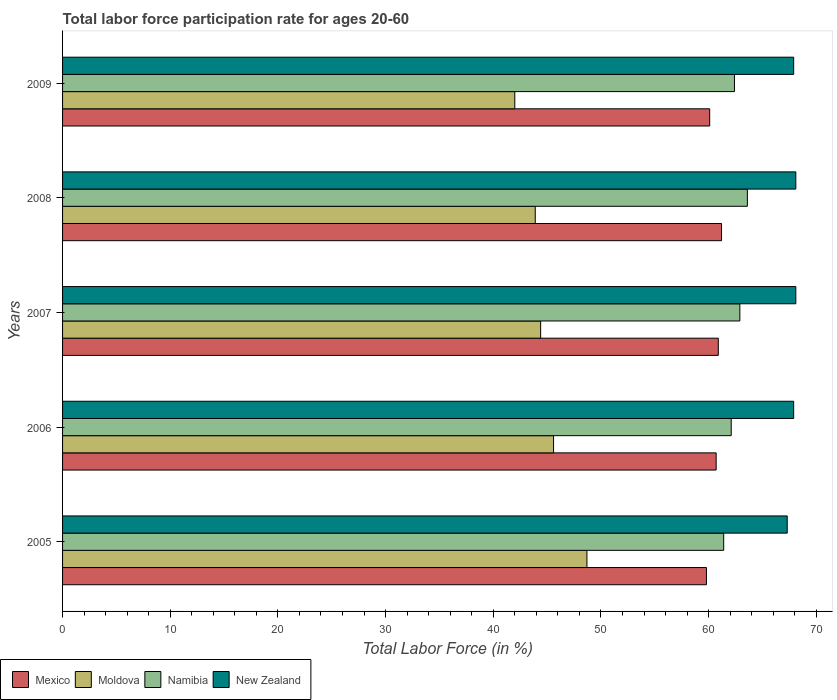How many groups of bars are there?
Keep it short and to the point. 5. Are the number of bars per tick equal to the number of legend labels?
Ensure brevity in your answer.  Yes. How many bars are there on the 2nd tick from the bottom?
Ensure brevity in your answer.  4. In how many cases, is the number of bars for a given year not equal to the number of legend labels?
Your answer should be very brief. 0. What is the labor force participation rate in Mexico in 2005?
Your answer should be very brief. 59.8. Across all years, what is the maximum labor force participation rate in Namibia?
Offer a terse response. 63.6. Across all years, what is the minimum labor force participation rate in New Zealand?
Give a very brief answer. 67.3. In which year was the labor force participation rate in Mexico maximum?
Offer a very short reply. 2008. What is the total labor force participation rate in New Zealand in the graph?
Your answer should be compact. 339.3. What is the difference between the labor force participation rate in New Zealand in 2007 and that in 2009?
Ensure brevity in your answer.  0.2. What is the difference between the labor force participation rate in Namibia in 2005 and the labor force participation rate in Mexico in 2008?
Provide a short and direct response. 0.2. What is the average labor force participation rate in New Zealand per year?
Your answer should be compact. 67.86. In the year 2007, what is the difference between the labor force participation rate in Moldova and labor force participation rate in Namibia?
Ensure brevity in your answer.  -18.5. What is the ratio of the labor force participation rate in Moldova in 2006 to that in 2008?
Offer a very short reply. 1.04. What is the difference between the highest and the second highest labor force participation rate in Mexico?
Your answer should be very brief. 0.3. What is the difference between the highest and the lowest labor force participation rate in New Zealand?
Offer a very short reply. 0.8. What does the 4th bar from the top in 2009 represents?
Offer a very short reply. Mexico. What does the 2nd bar from the bottom in 2007 represents?
Your response must be concise. Moldova. How many bars are there?
Your answer should be very brief. 20. Are the values on the major ticks of X-axis written in scientific E-notation?
Your response must be concise. No. Does the graph contain grids?
Give a very brief answer. No. How are the legend labels stacked?
Your answer should be compact. Horizontal. What is the title of the graph?
Offer a very short reply. Total labor force participation rate for ages 20-60. What is the Total Labor Force (in %) of Mexico in 2005?
Your answer should be compact. 59.8. What is the Total Labor Force (in %) in Moldova in 2005?
Your answer should be very brief. 48.7. What is the Total Labor Force (in %) of Namibia in 2005?
Make the answer very short. 61.4. What is the Total Labor Force (in %) in New Zealand in 2005?
Provide a short and direct response. 67.3. What is the Total Labor Force (in %) in Mexico in 2006?
Your answer should be very brief. 60.7. What is the Total Labor Force (in %) of Moldova in 2006?
Your answer should be very brief. 45.6. What is the Total Labor Force (in %) in Namibia in 2006?
Offer a very short reply. 62.1. What is the Total Labor Force (in %) in New Zealand in 2006?
Your answer should be compact. 67.9. What is the Total Labor Force (in %) in Mexico in 2007?
Keep it short and to the point. 60.9. What is the Total Labor Force (in %) of Moldova in 2007?
Provide a short and direct response. 44.4. What is the Total Labor Force (in %) of Namibia in 2007?
Your answer should be compact. 62.9. What is the Total Labor Force (in %) in New Zealand in 2007?
Your answer should be compact. 68.1. What is the Total Labor Force (in %) of Mexico in 2008?
Give a very brief answer. 61.2. What is the Total Labor Force (in %) of Moldova in 2008?
Provide a short and direct response. 43.9. What is the Total Labor Force (in %) in Namibia in 2008?
Provide a succinct answer. 63.6. What is the Total Labor Force (in %) in New Zealand in 2008?
Your answer should be compact. 68.1. What is the Total Labor Force (in %) in Mexico in 2009?
Offer a very short reply. 60.1. What is the Total Labor Force (in %) in Moldova in 2009?
Your response must be concise. 42. What is the Total Labor Force (in %) in Namibia in 2009?
Keep it short and to the point. 62.4. What is the Total Labor Force (in %) of New Zealand in 2009?
Make the answer very short. 67.9. Across all years, what is the maximum Total Labor Force (in %) of Mexico?
Offer a very short reply. 61.2. Across all years, what is the maximum Total Labor Force (in %) of Moldova?
Make the answer very short. 48.7. Across all years, what is the maximum Total Labor Force (in %) in Namibia?
Provide a succinct answer. 63.6. Across all years, what is the maximum Total Labor Force (in %) of New Zealand?
Make the answer very short. 68.1. Across all years, what is the minimum Total Labor Force (in %) in Mexico?
Ensure brevity in your answer.  59.8. Across all years, what is the minimum Total Labor Force (in %) of Namibia?
Provide a succinct answer. 61.4. Across all years, what is the minimum Total Labor Force (in %) in New Zealand?
Give a very brief answer. 67.3. What is the total Total Labor Force (in %) of Mexico in the graph?
Your answer should be very brief. 302.7. What is the total Total Labor Force (in %) in Moldova in the graph?
Give a very brief answer. 224.6. What is the total Total Labor Force (in %) in Namibia in the graph?
Give a very brief answer. 312.4. What is the total Total Labor Force (in %) of New Zealand in the graph?
Make the answer very short. 339.3. What is the difference between the Total Labor Force (in %) of New Zealand in 2005 and that in 2006?
Provide a short and direct response. -0.6. What is the difference between the Total Labor Force (in %) of Mexico in 2005 and that in 2007?
Your answer should be compact. -1.1. What is the difference between the Total Labor Force (in %) of Moldova in 2005 and that in 2007?
Provide a succinct answer. 4.3. What is the difference between the Total Labor Force (in %) in Namibia in 2005 and that in 2007?
Offer a very short reply. -1.5. What is the difference between the Total Labor Force (in %) in Mexico in 2005 and that in 2008?
Provide a succinct answer. -1.4. What is the difference between the Total Labor Force (in %) of Moldova in 2005 and that in 2008?
Your response must be concise. 4.8. What is the difference between the Total Labor Force (in %) of Namibia in 2005 and that in 2008?
Keep it short and to the point. -2.2. What is the difference between the Total Labor Force (in %) of New Zealand in 2005 and that in 2008?
Provide a succinct answer. -0.8. What is the difference between the Total Labor Force (in %) in Mexico in 2005 and that in 2009?
Your answer should be compact. -0.3. What is the difference between the Total Labor Force (in %) in Moldova in 2005 and that in 2009?
Make the answer very short. 6.7. What is the difference between the Total Labor Force (in %) in Moldova in 2006 and that in 2007?
Your answer should be very brief. 1.2. What is the difference between the Total Labor Force (in %) of New Zealand in 2006 and that in 2007?
Keep it short and to the point. -0.2. What is the difference between the Total Labor Force (in %) in Mexico in 2006 and that in 2008?
Your response must be concise. -0.5. What is the difference between the Total Labor Force (in %) in Moldova in 2006 and that in 2008?
Provide a succinct answer. 1.7. What is the difference between the Total Labor Force (in %) of Namibia in 2006 and that in 2008?
Provide a succinct answer. -1.5. What is the difference between the Total Labor Force (in %) in Moldova in 2006 and that in 2009?
Keep it short and to the point. 3.6. What is the difference between the Total Labor Force (in %) of Namibia in 2006 and that in 2009?
Keep it short and to the point. -0.3. What is the difference between the Total Labor Force (in %) in Mexico in 2007 and that in 2008?
Make the answer very short. -0.3. What is the difference between the Total Labor Force (in %) in Moldova in 2007 and that in 2008?
Offer a very short reply. 0.5. What is the difference between the Total Labor Force (in %) of Namibia in 2007 and that in 2008?
Offer a terse response. -0.7. What is the difference between the Total Labor Force (in %) of Mexico in 2007 and that in 2009?
Provide a succinct answer. 0.8. What is the difference between the Total Labor Force (in %) in Namibia in 2007 and that in 2009?
Provide a short and direct response. 0.5. What is the difference between the Total Labor Force (in %) in New Zealand in 2007 and that in 2009?
Keep it short and to the point. 0.2. What is the difference between the Total Labor Force (in %) of Mexico in 2008 and that in 2009?
Offer a terse response. 1.1. What is the difference between the Total Labor Force (in %) in Moldova in 2008 and that in 2009?
Ensure brevity in your answer.  1.9. What is the difference between the Total Labor Force (in %) in Mexico in 2005 and the Total Labor Force (in %) in Namibia in 2006?
Make the answer very short. -2.3. What is the difference between the Total Labor Force (in %) in Mexico in 2005 and the Total Labor Force (in %) in New Zealand in 2006?
Your answer should be very brief. -8.1. What is the difference between the Total Labor Force (in %) of Moldova in 2005 and the Total Labor Force (in %) of New Zealand in 2006?
Your answer should be compact. -19.2. What is the difference between the Total Labor Force (in %) in Mexico in 2005 and the Total Labor Force (in %) in New Zealand in 2007?
Keep it short and to the point. -8.3. What is the difference between the Total Labor Force (in %) of Moldova in 2005 and the Total Labor Force (in %) of Namibia in 2007?
Give a very brief answer. -14.2. What is the difference between the Total Labor Force (in %) of Moldova in 2005 and the Total Labor Force (in %) of New Zealand in 2007?
Provide a short and direct response. -19.4. What is the difference between the Total Labor Force (in %) of Namibia in 2005 and the Total Labor Force (in %) of New Zealand in 2007?
Give a very brief answer. -6.7. What is the difference between the Total Labor Force (in %) in Mexico in 2005 and the Total Labor Force (in %) in New Zealand in 2008?
Offer a terse response. -8.3. What is the difference between the Total Labor Force (in %) in Moldova in 2005 and the Total Labor Force (in %) in Namibia in 2008?
Provide a short and direct response. -14.9. What is the difference between the Total Labor Force (in %) in Moldova in 2005 and the Total Labor Force (in %) in New Zealand in 2008?
Offer a terse response. -19.4. What is the difference between the Total Labor Force (in %) of Mexico in 2005 and the Total Labor Force (in %) of Moldova in 2009?
Provide a succinct answer. 17.8. What is the difference between the Total Labor Force (in %) in Mexico in 2005 and the Total Labor Force (in %) in New Zealand in 2009?
Make the answer very short. -8.1. What is the difference between the Total Labor Force (in %) in Moldova in 2005 and the Total Labor Force (in %) in Namibia in 2009?
Keep it short and to the point. -13.7. What is the difference between the Total Labor Force (in %) of Moldova in 2005 and the Total Labor Force (in %) of New Zealand in 2009?
Your response must be concise. -19.2. What is the difference between the Total Labor Force (in %) of Namibia in 2005 and the Total Labor Force (in %) of New Zealand in 2009?
Ensure brevity in your answer.  -6.5. What is the difference between the Total Labor Force (in %) in Moldova in 2006 and the Total Labor Force (in %) in Namibia in 2007?
Ensure brevity in your answer.  -17.3. What is the difference between the Total Labor Force (in %) of Moldova in 2006 and the Total Labor Force (in %) of New Zealand in 2007?
Offer a very short reply. -22.5. What is the difference between the Total Labor Force (in %) of Mexico in 2006 and the Total Labor Force (in %) of Namibia in 2008?
Your answer should be very brief. -2.9. What is the difference between the Total Labor Force (in %) in Moldova in 2006 and the Total Labor Force (in %) in Namibia in 2008?
Your response must be concise. -18. What is the difference between the Total Labor Force (in %) in Moldova in 2006 and the Total Labor Force (in %) in New Zealand in 2008?
Your answer should be compact. -22.5. What is the difference between the Total Labor Force (in %) of Moldova in 2006 and the Total Labor Force (in %) of Namibia in 2009?
Offer a very short reply. -16.8. What is the difference between the Total Labor Force (in %) in Moldova in 2006 and the Total Labor Force (in %) in New Zealand in 2009?
Ensure brevity in your answer.  -22.3. What is the difference between the Total Labor Force (in %) of Mexico in 2007 and the Total Labor Force (in %) of Moldova in 2008?
Keep it short and to the point. 17. What is the difference between the Total Labor Force (in %) of Mexico in 2007 and the Total Labor Force (in %) of New Zealand in 2008?
Your answer should be compact. -7.2. What is the difference between the Total Labor Force (in %) of Moldova in 2007 and the Total Labor Force (in %) of Namibia in 2008?
Your response must be concise. -19.2. What is the difference between the Total Labor Force (in %) of Moldova in 2007 and the Total Labor Force (in %) of New Zealand in 2008?
Offer a terse response. -23.7. What is the difference between the Total Labor Force (in %) in Namibia in 2007 and the Total Labor Force (in %) in New Zealand in 2008?
Your answer should be compact. -5.2. What is the difference between the Total Labor Force (in %) in Mexico in 2007 and the Total Labor Force (in %) in Moldova in 2009?
Ensure brevity in your answer.  18.9. What is the difference between the Total Labor Force (in %) in Mexico in 2007 and the Total Labor Force (in %) in New Zealand in 2009?
Offer a terse response. -7. What is the difference between the Total Labor Force (in %) in Moldova in 2007 and the Total Labor Force (in %) in New Zealand in 2009?
Your answer should be very brief. -23.5. What is the difference between the Total Labor Force (in %) in Namibia in 2007 and the Total Labor Force (in %) in New Zealand in 2009?
Keep it short and to the point. -5. What is the difference between the Total Labor Force (in %) of Mexico in 2008 and the Total Labor Force (in %) of Namibia in 2009?
Give a very brief answer. -1.2. What is the difference between the Total Labor Force (in %) in Moldova in 2008 and the Total Labor Force (in %) in Namibia in 2009?
Keep it short and to the point. -18.5. What is the difference between the Total Labor Force (in %) of Namibia in 2008 and the Total Labor Force (in %) of New Zealand in 2009?
Provide a succinct answer. -4.3. What is the average Total Labor Force (in %) of Mexico per year?
Your response must be concise. 60.54. What is the average Total Labor Force (in %) of Moldova per year?
Provide a succinct answer. 44.92. What is the average Total Labor Force (in %) in Namibia per year?
Your answer should be very brief. 62.48. What is the average Total Labor Force (in %) in New Zealand per year?
Your answer should be compact. 67.86. In the year 2005, what is the difference between the Total Labor Force (in %) of Moldova and Total Labor Force (in %) of Namibia?
Your answer should be compact. -12.7. In the year 2005, what is the difference between the Total Labor Force (in %) of Moldova and Total Labor Force (in %) of New Zealand?
Offer a very short reply. -18.6. In the year 2005, what is the difference between the Total Labor Force (in %) of Namibia and Total Labor Force (in %) of New Zealand?
Your response must be concise. -5.9. In the year 2006, what is the difference between the Total Labor Force (in %) in Mexico and Total Labor Force (in %) in Moldova?
Your response must be concise. 15.1. In the year 2006, what is the difference between the Total Labor Force (in %) of Mexico and Total Labor Force (in %) of Namibia?
Offer a terse response. -1.4. In the year 2006, what is the difference between the Total Labor Force (in %) in Mexico and Total Labor Force (in %) in New Zealand?
Offer a very short reply. -7.2. In the year 2006, what is the difference between the Total Labor Force (in %) of Moldova and Total Labor Force (in %) of Namibia?
Give a very brief answer. -16.5. In the year 2006, what is the difference between the Total Labor Force (in %) in Moldova and Total Labor Force (in %) in New Zealand?
Make the answer very short. -22.3. In the year 2006, what is the difference between the Total Labor Force (in %) in Namibia and Total Labor Force (in %) in New Zealand?
Your answer should be compact. -5.8. In the year 2007, what is the difference between the Total Labor Force (in %) of Mexico and Total Labor Force (in %) of Namibia?
Provide a succinct answer. -2. In the year 2007, what is the difference between the Total Labor Force (in %) of Mexico and Total Labor Force (in %) of New Zealand?
Provide a succinct answer. -7.2. In the year 2007, what is the difference between the Total Labor Force (in %) of Moldova and Total Labor Force (in %) of Namibia?
Provide a succinct answer. -18.5. In the year 2007, what is the difference between the Total Labor Force (in %) in Moldova and Total Labor Force (in %) in New Zealand?
Give a very brief answer. -23.7. In the year 2008, what is the difference between the Total Labor Force (in %) of Mexico and Total Labor Force (in %) of Namibia?
Offer a terse response. -2.4. In the year 2008, what is the difference between the Total Labor Force (in %) in Mexico and Total Labor Force (in %) in New Zealand?
Give a very brief answer. -6.9. In the year 2008, what is the difference between the Total Labor Force (in %) in Moldova and Total Labor Force (in %) in Namibia?
Your response must be concise. -19.7. In the year 2008, what is the difference between the Total Labor Force (in %) of Moldova and Total Labor Force (in %) of New Zealand?
Make the answer very short. -24.2. In the year 2008, what is the difference between the Total Labor Force (in %) in Namibia and Total Labor Force (in %) in New Zealand?
Your answer should be very brief. -4.5. In the year 2009, what is the difference between the Total Labor Force (in %) in Mexico and Total Labor Force (in %) in New Zealand?
Give a very brief answer. -7.8. In the year 2009, what is the difference between the Total Labor Force (in %) of Moldova and Total Labor Force (in %) of Namibia?
Ensure brevity in your answer.  -20.4. In the year 2009, what is the difference between the Total Labor Force (in %) of Moldova and Total Labor Force (in %) of New Zealand?
Offer a terse response. -25.9. In the year 2009, what is the difference between the Total Labor Force (in %) of Namibia and Total Labor Force (in %) of New Zealand?
Provide a succinct answer. -5.5. What is the ratio of the Total Labor Force (in %) in Mexico in 2005 to that in 2006?
Your answer should be compact. 0.99. What is the ratio of the Total Labor Force (in %) in Moldova in 2005 to that in 2006?
Your answer should be very brief. 1.07. What is the ratio of the Total Labor Force (in %) in Namibia in 2005 to that in 2006?
Your response must be concise. 0.99. What is the ratio of the Total Labor Force (in %) of Mexico in 2005 to that in 2007?
Provide a short and direct response. 0.98. What is the ratio of the Total Labor Force (in %) in Moldova in 2005 to that in 2007?
Make the answer very short. 1.1. What is the ratio of the Total Labor Force (in %) of Namibia in 2005 to that in 2007?
Offer a very short reply. 0.98. What is the ratio of the Total Labor Force (in %) in New Zealand in 2005 to that in 2007?
Your answer should be compact. 0.99. What is the ratio of the Total Labor Force (in %) of Mexico in 2005 to that in 2008?
Your answer should be very brief. 0.98. What is the ratio of the Total Labor Force (in %) in Moldova in 2005 to that in 2008?
Make the answer very short. 1.11. What is the ratio of the Total Labor Force (in %) of Namibia in 2005 to that in 2008?
Ensure brevity in your answer.  0.97. What is the ratio of the Total Labor Force (in %) in New Zealand in 2005 to that in 2008?
Provide a succinct answer. 0.99. What is the ratio of the Total Labor Force (in %) in Mexico in 2005 to that in 2009?
Keep it short and to the point. 0.99. What is the ratio of the Total Labor Force (in %) of Moldova in 2005 to that in 2009?
Your response must be concise. 1.16. What is the ratio of the Total Labor Force (in %) of Namibia in 2005 to that in 2009?
Make the answer very short. 0.98. What is the ratio of the Total Labor Force (in %) of New Zealand in 2005 to that in 2009?
Provide a succinct answer. 0.99. What is the ratio of the Total Labor Force (in %) in Namibia in 2006 to that in 2007?
Your response must be concise. 0.99. What is the ratio of the Total Labor Force (in %) in New Zealand in 2006 to that in 2007?
Your answer should be very brief. 1. What is the ratio of the Total Labor Force (in %) of Moldova in 2006 to that in 2008?
Make the answer very short. 1.04. What is the ratio of the Total Labor Force (in %) in Namibia in 2006 to that in 2008?
Your answer should be compact. 0.98. What is the ratio of the Total Labor Force (in %) in Mexico in 2006 to that in 2009?
Provide a succinct answer. 1.01. What is the ratio of the Total Labor Force (in %) in Moldova in 2006 to that in 2009?
Make the answer very short. 1.09. What is the ratio of the Total Labor Force (in %) in New Zealand in 2006 to that in 2009?
Give a very brief answer. 1. What is the ratio of the Total Labor Force (in %) of Moldova in 2007 to that in 2008?
Ensure brevity in your answer.  1.01. What is the ratio of the Total Labor Force (in %) in New Zealand in 2007 to that in 2008?
Make the answer very short. 1. What is the ratio of the Total Labor Force (in %) in Mexico in 2007 to that in 2009?
Provide a succinct answer. 1.01. What is the ratio of the Total Labor Force (in %) of Moldova in 2007 to that in 2009?
Keep it short and to the point. 1.06. What is the ratio of the Total Labor Force (in %) in Namibia in 2007 to that in 2009?
Offer a very short reply. 1.01. What is the ratio of the Total Labor Force (in %) of New Zealand in 2007 to that in 2009?
Your response must be concise. 1. What is the ratio of the Total Labor Force (in %) in Mexico in 2008 to that in 2009?
Offer a very short reply. 1.02. What is the ratio of the Total Labor Force (in %) of Moldova in 2008 to that in 2009?
Provide a succinct answer. 1.05. What is the ratio of the Total Labor Force (in %) in Namibia in 2008 to that in 2009?
Provide a short and direct response. 1.02. What is the ratio of the Total Labor Force (in %) of New Zealand in 2008 to that in 2009?
Ensure brevity in your answer.  1. What is the difference between the highest and the second highest Total Labor Force (in %) in Moldova?
Give a very brief answer. 3.1. What is the difference between the highest and the second highest Total Labor Force (in %) of Namibia?
Make the answer very short. 0.7. What is the difference between the highest and the second highest Total Labor Force (in %) of New Zealand?
Offer a terse response. 0. What is the difference between the highest and the lowest Total Labor Force (in %) of Mexico?
Give a very brief answer. 1.4. What is the difference between the highest and the lowest Total Labor Force (in %) in Moldova?
Provide a short and direct response. 6.7. What is the difference between the highest and the lowest Total Labor Force (in %) in Namibia?
Your answer should be compact. 2.2. 